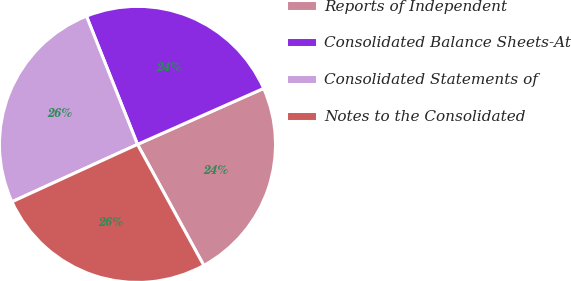<chart> <loc_0><loc_0><loc_500><loc_500><pie_chart><fcel>Reports of Independent<fcel>Consolidated Balance Sheets-At<fcel>Consolidated Statements of<fcel>Notes to the Consolidated<nl><fcel>23.67%<fcel>24.38%<fcel>25.8%<fcel>26.15%<nl></chart> 